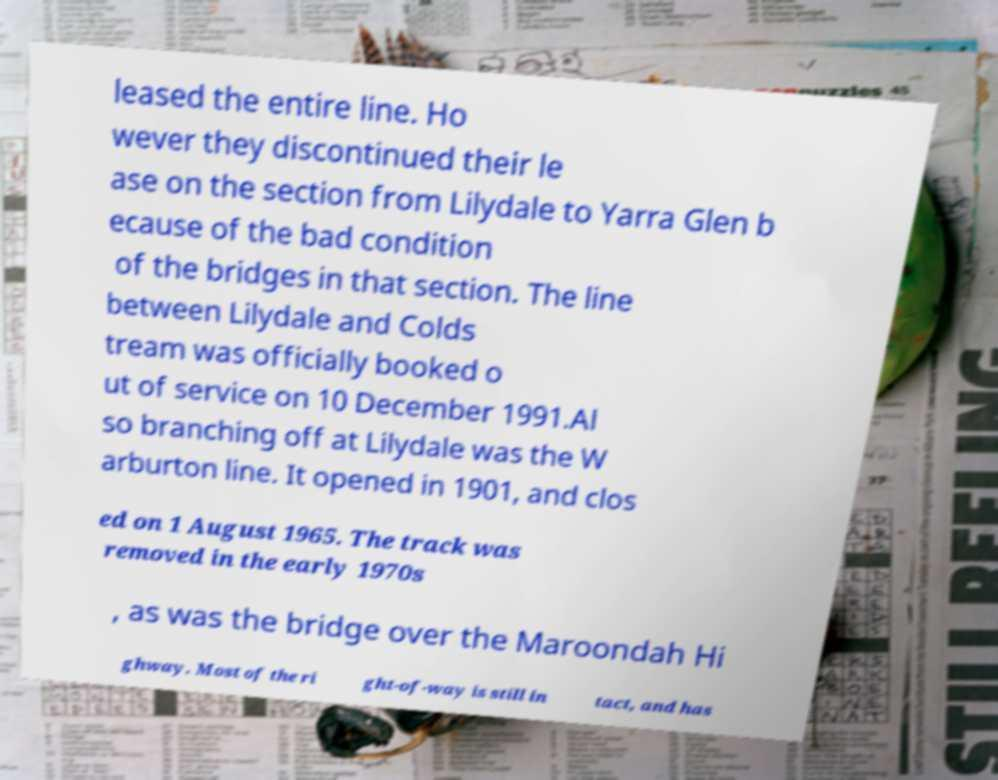What messages or text are displayed in this image? I need them in a readable, typed format. leased the entire line. Ho wever they discontinued their le ase on the section from Lilydale to Yarra Glen b ecause of the bad condition of the bridges in that section. The line between Lilydale and Colds tream was officially booked o ut of service on 10 December 1991.Al so branching off at Lilydale was the W arburton line. It opened in 1901, and clos ed on 1 August 1965. The track was removed in the early 1970s , as was the bridge over the Maroondah Hi ghway. Most of the ri ght-of-way is still in tact, and has 